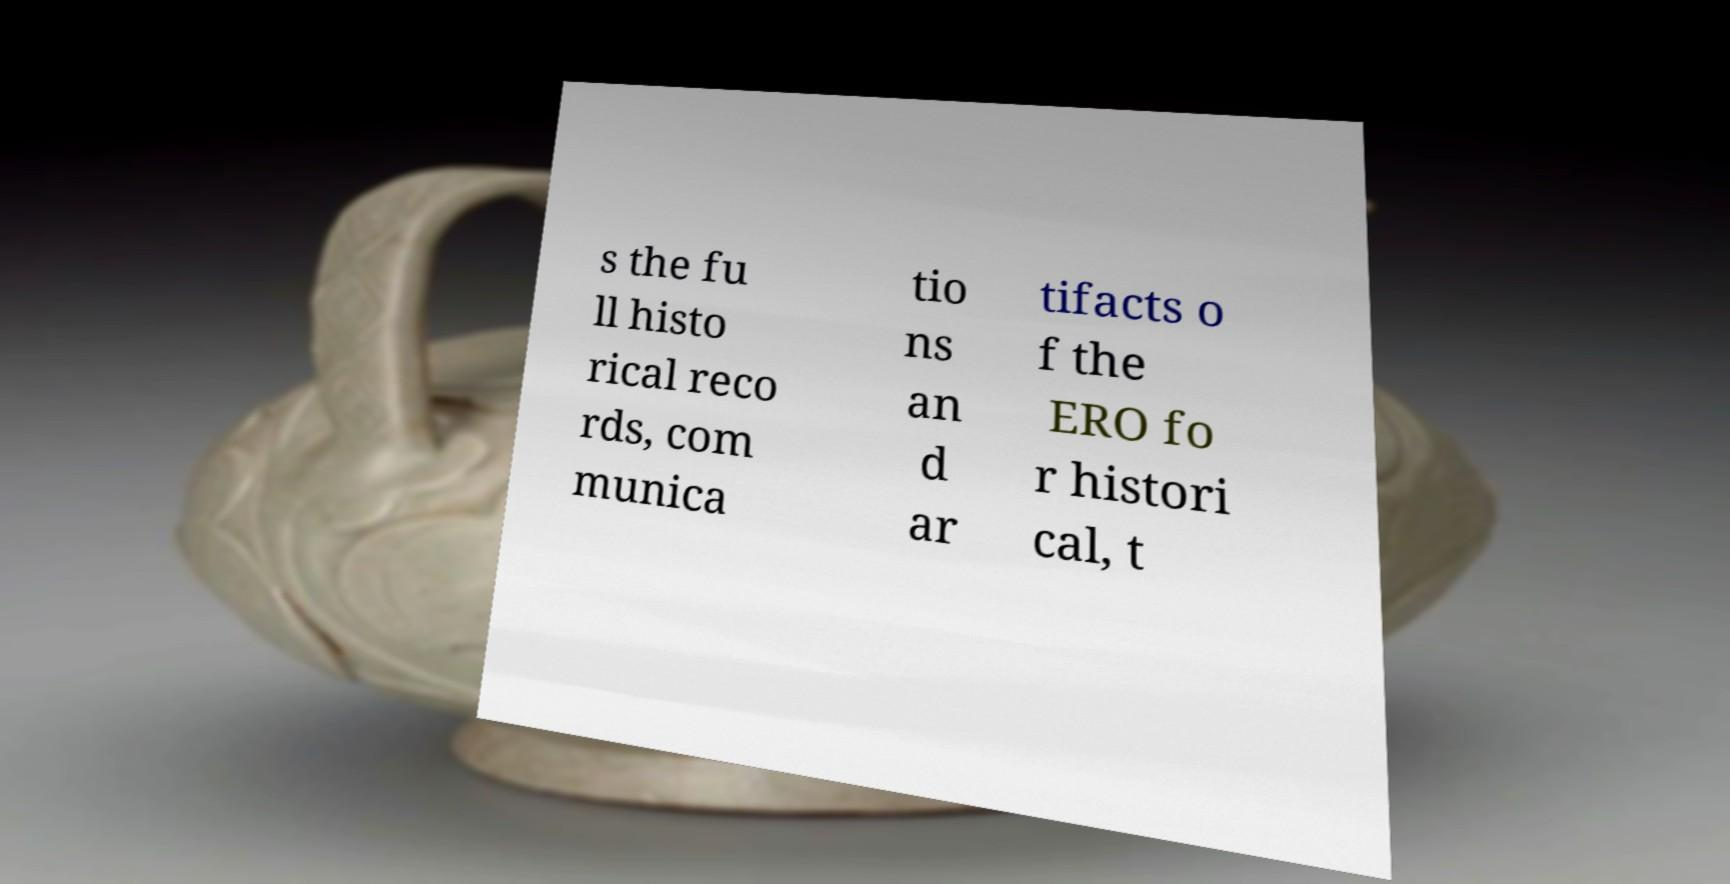Please read and relay the text visible in this image. What does it say? s the fu ll histo rical reco rds, com munica tio ns an d ar tifacts o f the ERO fo r histori cal, t 